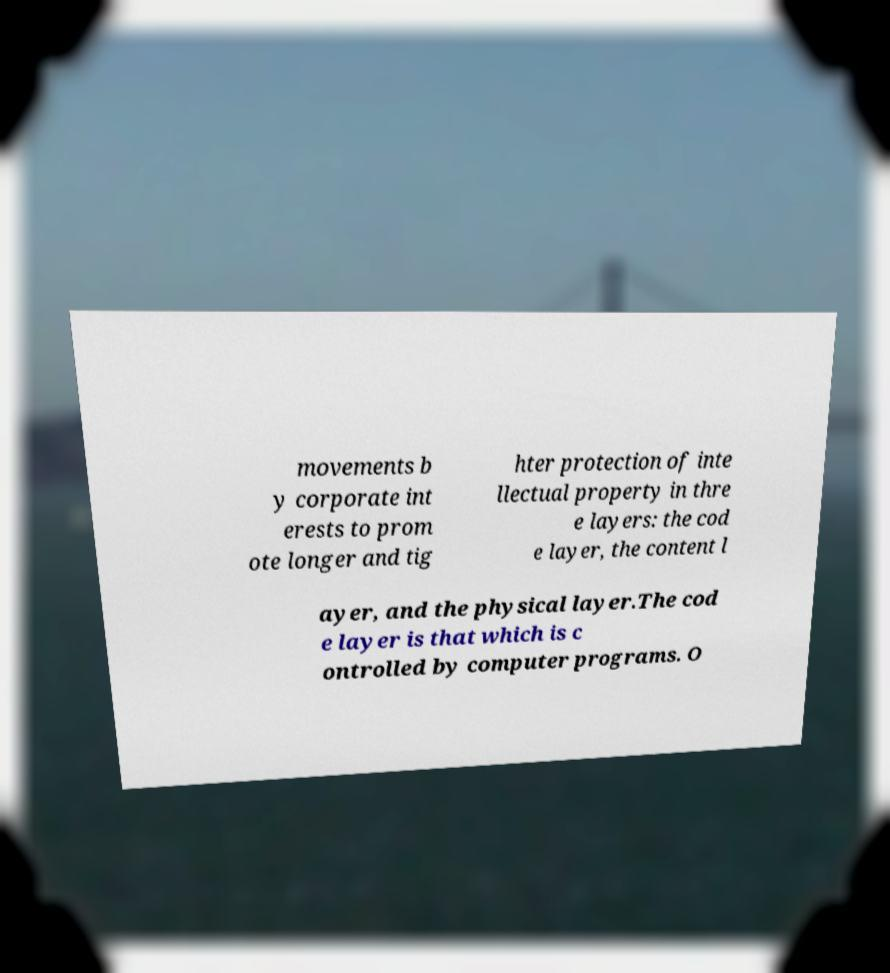What messages or text are displayed in this image? I need them in a readable, typed format. movements b y corporate int erests to prom ote longer and tig hter protection of inte llectual property in thre e layers: the cod e layer, the content l ayer, and the physical layer.The cod e layer is that which is c ontrolled by computer programs. O 